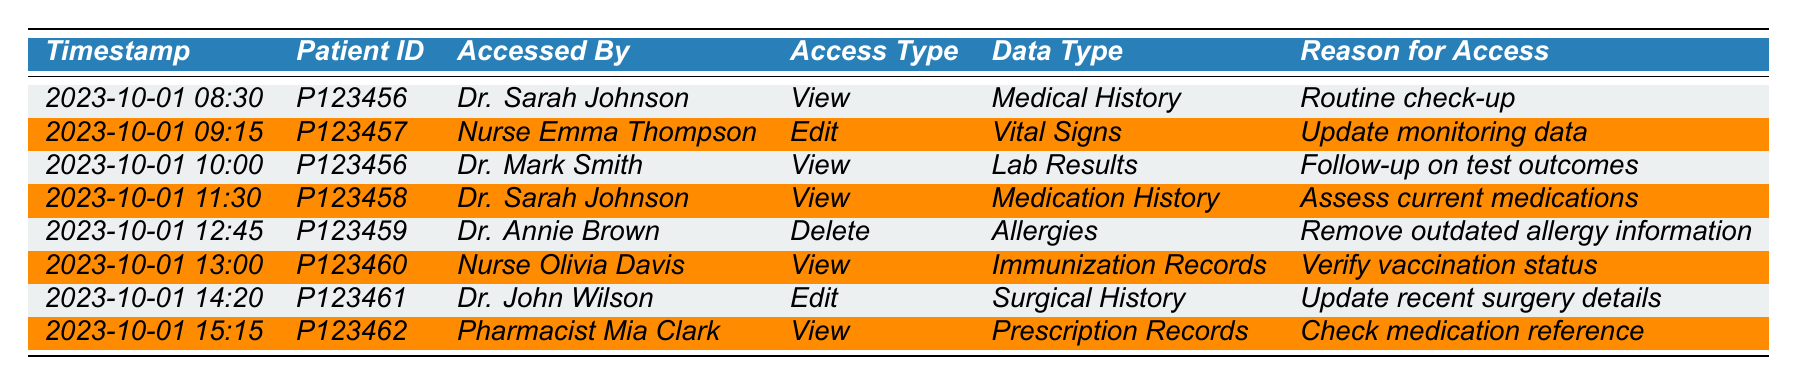What type of data did Dr. Sarah Johnson access on 2023-10-01? According to the table, Dr. Sarah Johnson accessed information on two occasions on the specified date. The types of data accessed were "Medical History" at 08:30 and "Medication History" at 11:30.
Answer: Medical History, Medication History How many total access logs were made to patient records on 2023-10-01? The table consists of eight rows, each representing a unique access log entry for that date. Thus, the total number of access logs is simply the number of entries in the table.
Answer: 8 Was there any deletion of data on 2023-10-01? Looking through the access logs, there is one entry that indicates a "Delete" action for patient P123459 regarding "Allergies." Thus, the presence of a deletion is confirmed.
Answer: Yes Which healthcare professional accessed the most varied types of data? To determine this, we can list the types of data each professional accessed and count them. Dr. Sarah Johnson accessed Medical History and Medication History (2 types). Dr. Annie Brown accessed 1 type. Nurse Olivia Davis accessed 1 type. Dr. Mark Smith and Dr. John Wilson each accessed 1 type. Pharmacist Mia Clark accessed 1 type. Therefore, Dr. Sarah Johnson has the most varied access.
Answer: Dr. Sarah Johnson How many distinct healthcare professionals accessed patient data? By reviewing the "Accessed By" column, we can identify distinct professionals: Dr. Sarah Johnson, Nurse Emma Thompson, Dr. Mark Smith, Dr. Annie Brown, Nurse Olivia Davis, Dr. John Wilson, and Pharmacist Mia Clark. Counting them gives us 7 unique professionals.
Answer: 7 What is the reason given for Dr. Annie Brown's access to patient records? The table provides the reason for each access on 2023-10-01. For Dr. Annie Brown, who accessed information at 12:45, the reason stated is "Remove outdated allergy information."
Answer: Remove outdated allergy information How many times was patient P123456 accessed on the specified date? The access logs show that patient P123456 was accessed twice: first for "Medical History" and second for "Lab Results." Thus, we can simply count those entries.
Answer: 2 What was the most common access type among all entries? By inspecting the table, we see that there are 5 "View," 2 "Edit," and 1 "Delete" transactions. The access type "View" appears the most frequently, at 5 occurrences.
Answer: View What can be inferred about the access patterns of Dr. Sarah Johnson? Dr. Sarah Johnson accessed patient data twice, both for different types of data within the same morning. This indicates she is actively engaged with multiple patients and checks their records on the same day.
Answer: Engaged with multiple patients What is the purpose of accessing the "Immunization Records"? The table indicates that Nurse Olivia Davis accessed "Immunization Records" for the reason "Verify vaccination status." This suggests a purpose tied to ensuring patient health compliance.
Answer: Verify vaccination status 